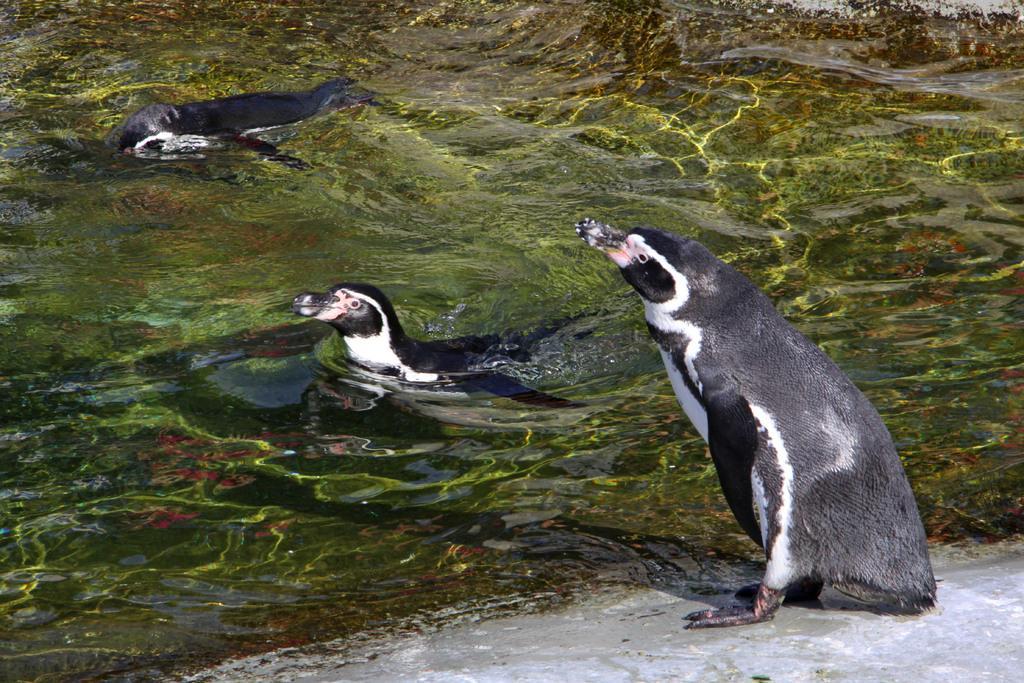How would you summarize this image in a sentence or two? In this picture we can see snares penguins in the water. 